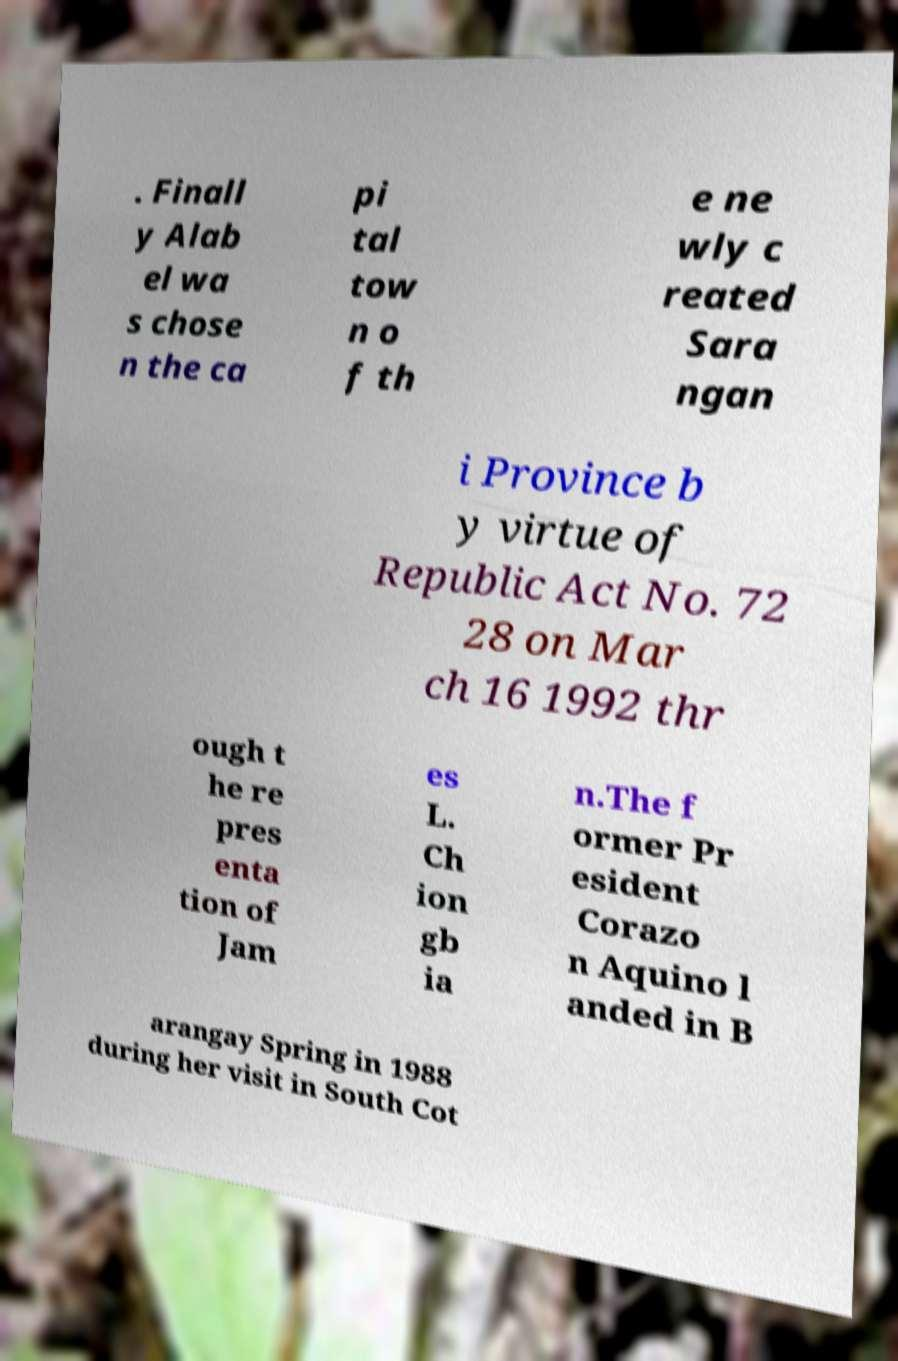Could you extract and type out the text from this image? . Finall y Alab el wa s chose n the ca pi tal tow n o f th e ne wly c reated Sara ngan i Province b y virtue of Republic Act No. 72 28 on Mar ch 16 1992 thr ough t he re pres enta tion of Jam es L. Ch ion gb ia n.The f ormer Pr esident Corazo n Aquino l anded in B arangay Spring in 1988 during her visit in South Cot 